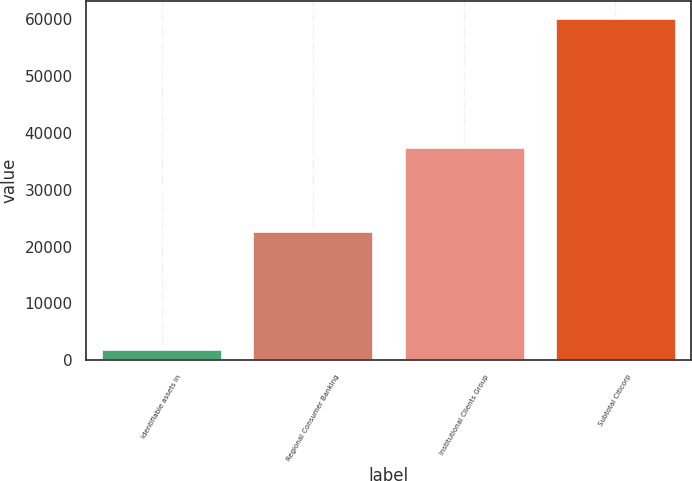<chart> <loc_0><loc_0><loc_500><loc_500><bar_chart><fcel>identifiable assets in<fcel>Regional Consumer Banking<fcel>Institutional Clients Group<fcel>Subtotal Citicorp<nl><fcel>2009<fcel>22771<fcel>37435<fcel>60206<nl></chart> 